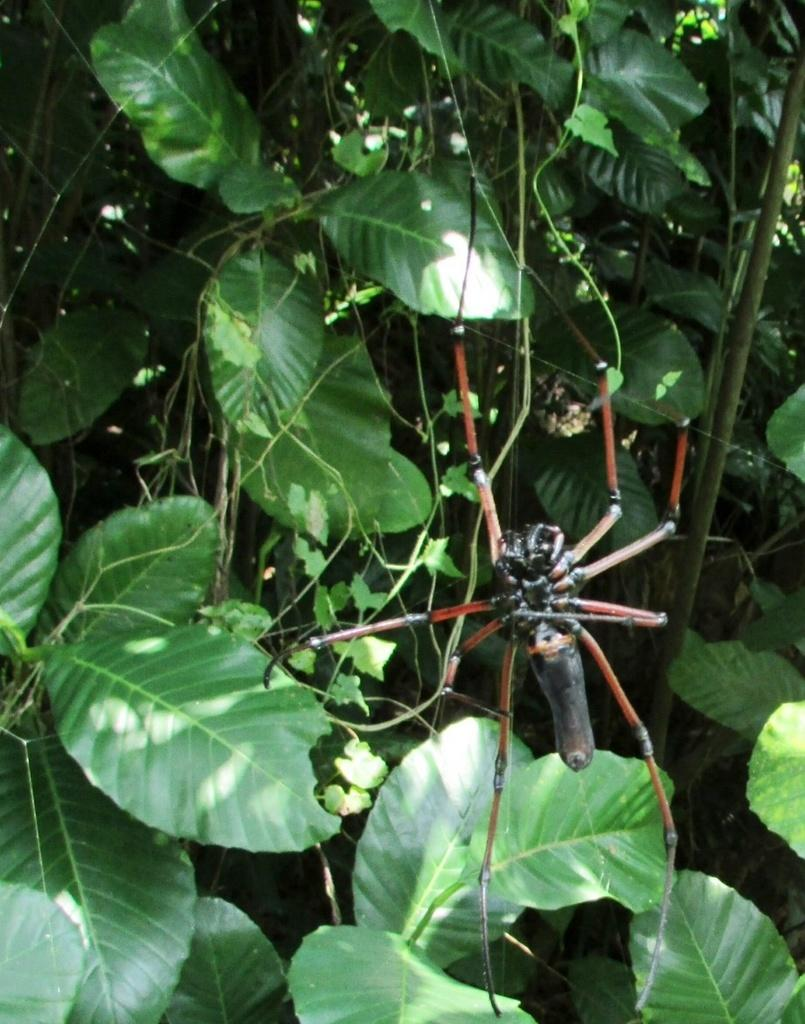What type of animal can be seen in the image? There is a spider in the image. What type of vegetation is present in the image? There are green leaves and stems in the image. What type of medical advice does the spider give to the leaves in the image? There is no indication in the image that the spider is providing medical advice to the leaves, as spiders do not have the ability to communicate or provide medical advice. 